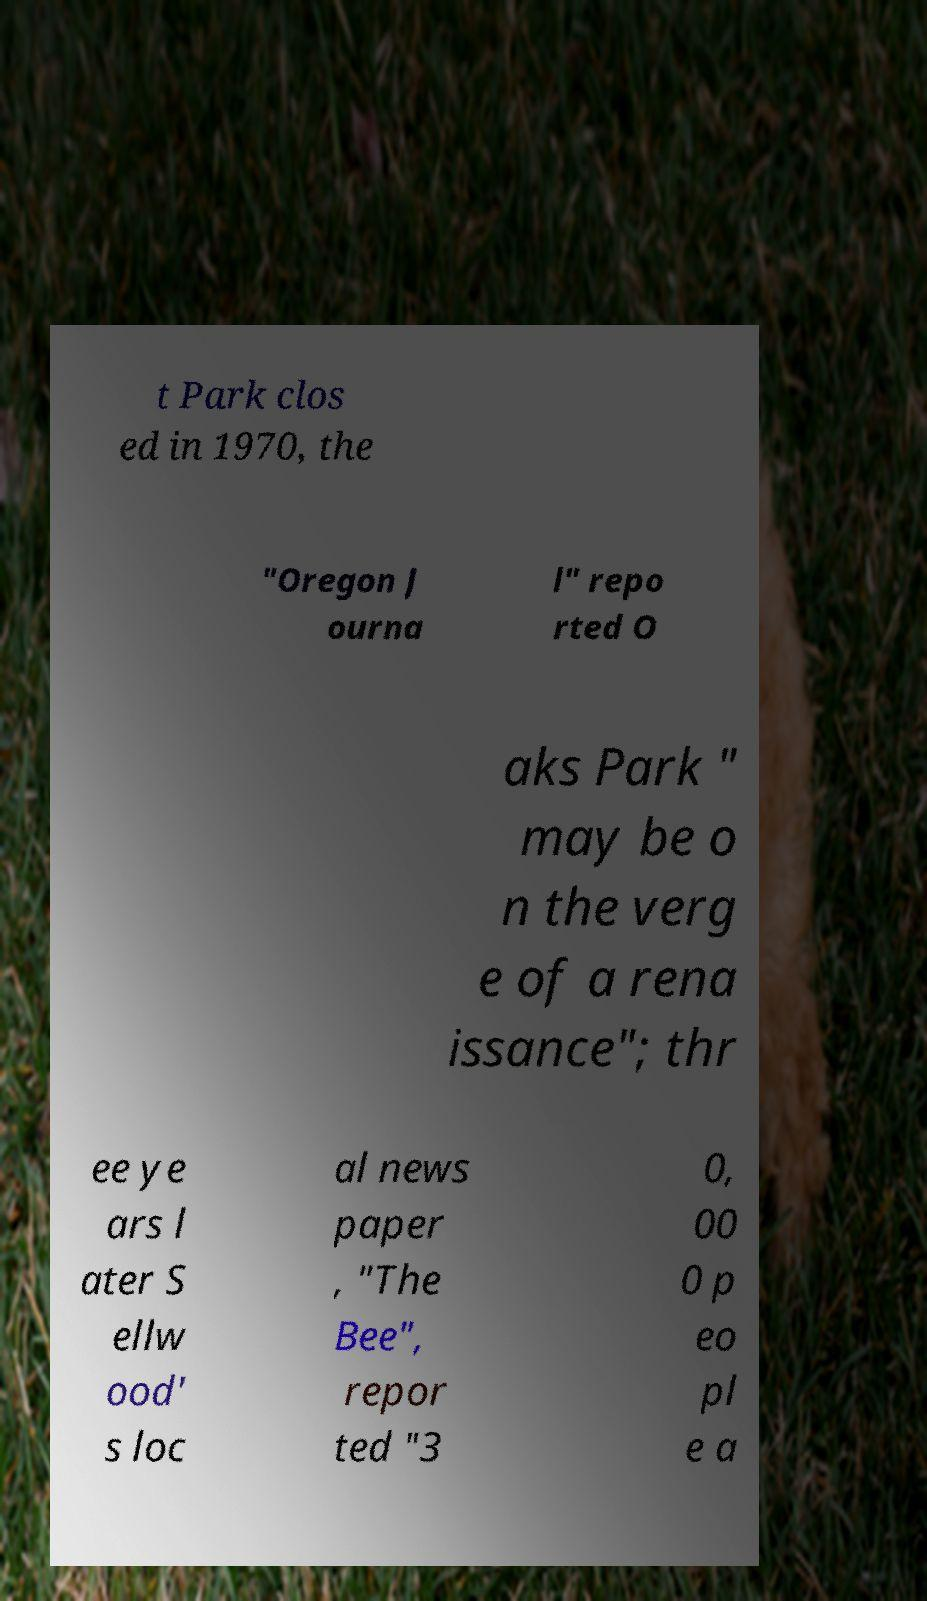There's text embedded in this image that I need extracted. Can you transcribe it verbatim? t Park clos ed in 1970, the "Oregon J ourna l" repo rted O aks Park " may be o n the verg e of a rena issance"; thr ee ye ars l ater S ellw ood' s loc al news paper , "The Bee", repor ted "3 0, 00 0 p eo pl e a 